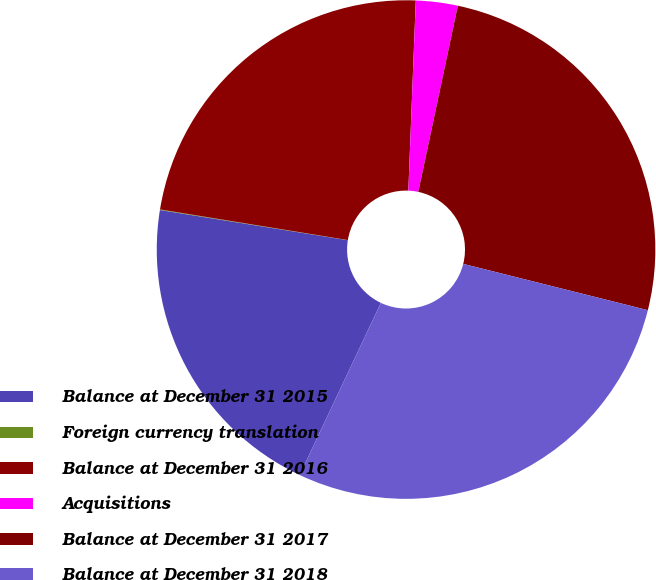Convert chart to OTSL. <chart><loc_0><loc_0><loc_500><loc_500><pie_chart><fcel>Balance at December 31 2015<fcel>Foreign currency translation<fcel>Balance at December 31 2016<fcel>Acquisitions<fcel>Balance at December 31 2017<fcel>Balance at December 31 2018<nl><fcel>20.52%<fcel>0.04%<fcel>23.05%<fcel>2.71%<fcel>25.58%<fcel>28.11%<nl></chart> 